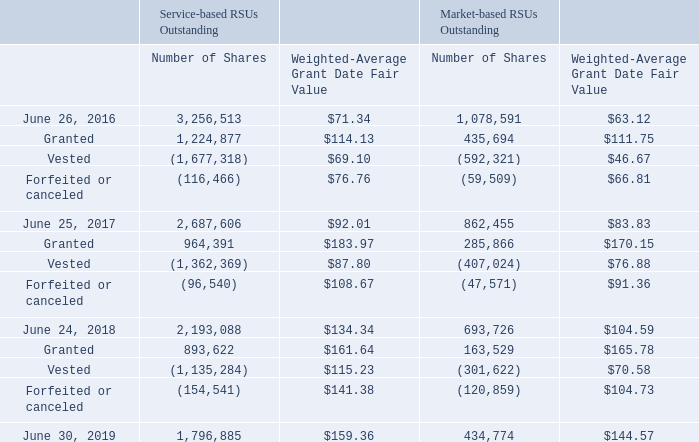Restricted Stock Units
During the fiscal years 2019, 2018, and 2017, the Company issued both service-based RSUs and market-based performance RSUs (“PRSUs”). Market-based PRSUs generally vest three years from the grant date if certain performance criteria are achieved and require continued employment. Based upon the terms of such awards, the number of shares that can be earned over the performance periods is based on the Company’s Common Stock price performance compared to the market price performance of the Philadelphia Semiconductor Sector Index (“SOX”), ranging from 0% to 150% of target. The stock price performance or market price performance is measured using the closing price for the 50-trading days prior to the dates the performance period begins and ends. The target number of shares represented by the market-based PRSUs is increased by 2% of target for each 1% that Common Stock price performance exceeds the market price performance of the SOX index. The result of the vesting formula is rounded down to the nearest whole number. Total stockholder return is a measure of stock price appreciation in this performance period.
The following table summarizes restricted stock activity:
The fair value of the Company’s service-based RSUs was calculated based on fair market value of the Company’s stock at the date of grant, discounted for dividends.
How long do market-based PRSUs usually vest from grant date? Three years. How is the stock price performance or market price performance measured? Using the closing price for the 50-trading days prior to the dates the performance period begins and ends. What is the number of shares as of June 26, 2016? 3,256,513. Which type of RSUs outstanding is higher as of June 26, 2016? Find the type of RSUs outstanding that is higher as of June 26, 2016
Answer: service-based rsus outstanding. Which type of RSUs outstanding is higher as of June 25, 2017? Find the type of RSUs outstanding that is higher as of June 25, 2017
Answer: service-based rsus outstanding. Which type of RSUs outstanding is higher as of June 30, 2019? Find the type of RSUs outstanding that is higher as June 25, 2017Find the type of RSUs outstanding that is higher as of June 30, 2019
Answer: service-based rsus outstanding. 